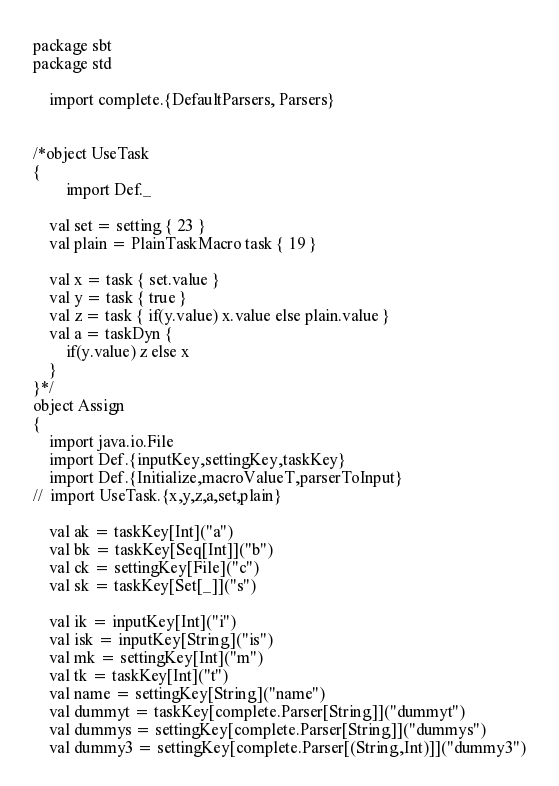Convert code to text. <code><loc_0><loc_0><loc_500><loc_500><_Scala_>package sbt
package std

	import complete.{DefaultParsers, Parsers}


/*object UseTask
{
		import Def._

	val set = setting { 23 }
	val plain = PlainTaskMacro task { 19 }

	val x = task { set.value }
	val y = task { true }
	val z = task { if(y.value) x.value else plain.value }
	val a = taskDyn { 
		if(y.value) z else x
	}
}*/
object Assign
{
	import java.io.File
	import Def.{inputKey,settingKey,taskKey}
	import Def.{Initialize,macroValueT,parserToInput}
//	import UseTask.{x,y,z,a,set,plain}

	val ak = taskKey[Int]("a")
	val bk = taskKey[Seq[Int]]("b")
	val ck = settingKey[File]("c")
	val sk = taskKey[Set[_]]("s")

	val ik = inputKey[Int]("i")
	val isk = inputKey[String]("is")
	val mk = settingKey[Int]("m")
	val tk = taskKey[Int]("t")
	val name = settingKey[String]("name")
	val dummyt = taskKey[complete.Parser[String]]("dummyt")
	val dummys = settingKey[complete.Parser[String]]("dummys")
	val dummy3 = settingKey[complete.Parser[(String,Int)]]("dummy3")</code> 